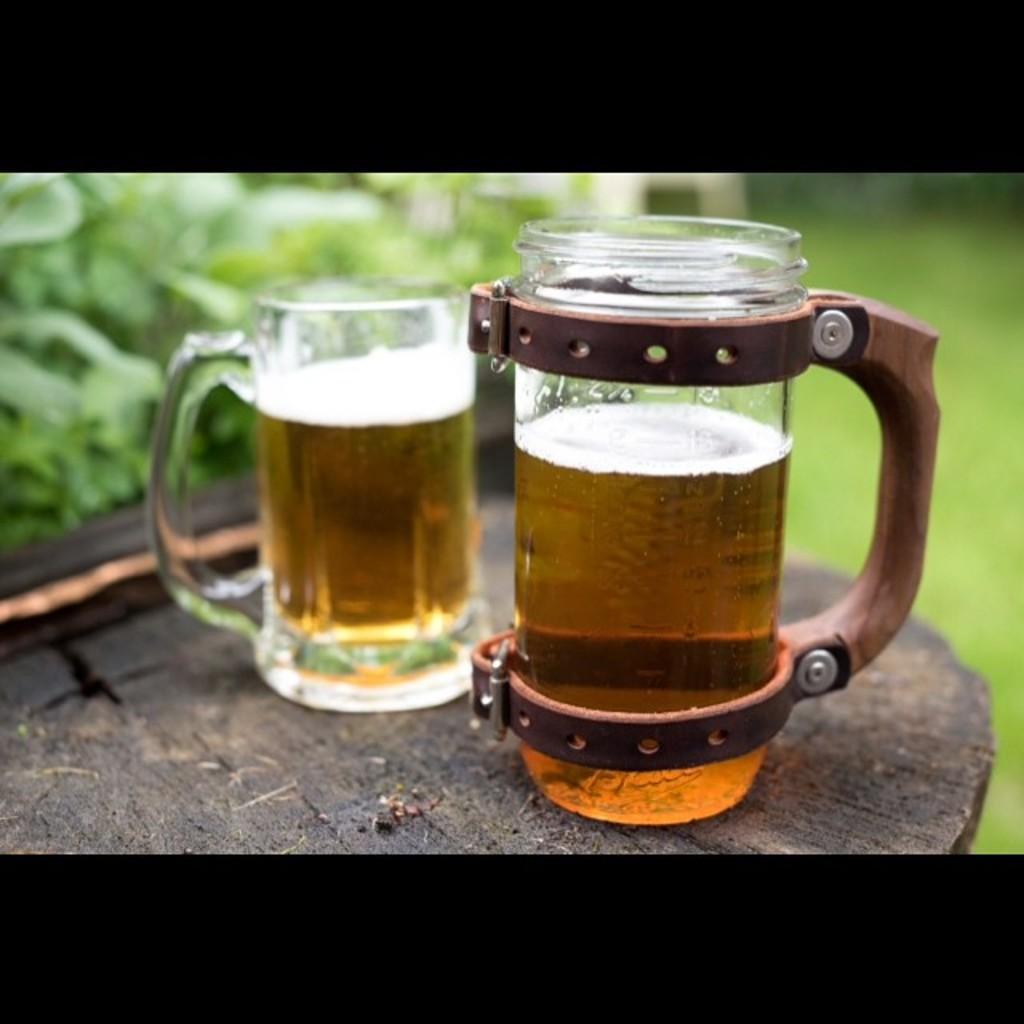Describe this image in one or two sentences. There are two mugs on the wooden surface in the foreground area of the image and the background is blurry. 